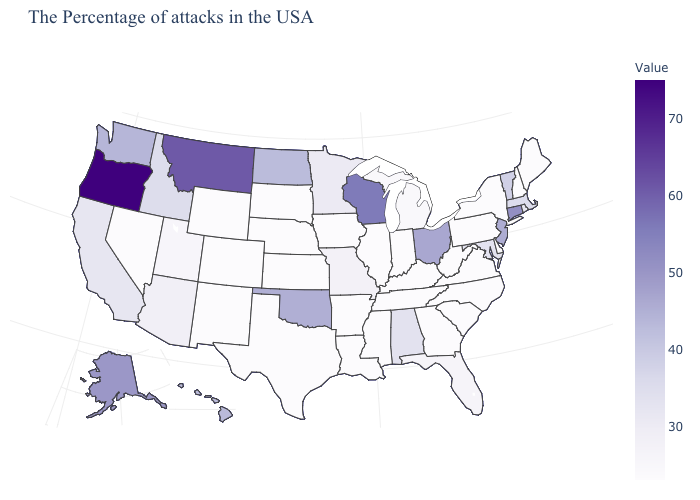Does Rhode Island have a lower value than Ohio?
Answer briefly. Yes. Does the map have missing data?
Concise answer only. No. Which states have the lowest value in the West?
Write a very short answer. Wyoming, Colorado, New Mexico, Nevada. Does Alabama have a lower value than Ohio?
Answer briefly. Yes. Among the states that border Wisconsin , does Illinois have the highest value?
Answer briefly. No. 